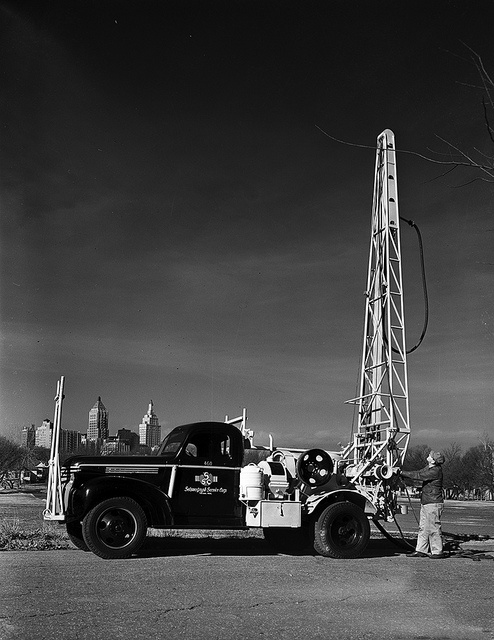Describe the objects in this image and their specific colors. I can see truck in black, gray, lightgray, and darkgray tones and people in black, gray, darkgray, and lightgray tones in this image. 